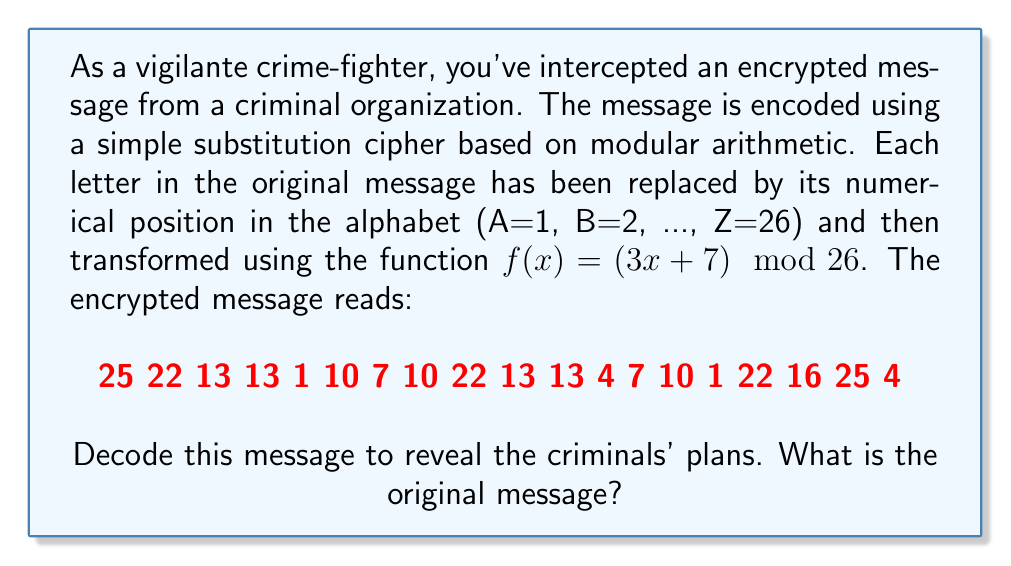Give your solution to this math problem. To decode the message, we need to reverse the encryption process:

1) First, we need to find the inverse function of $f(x) = (3x + 7) \mod 26$. 
   Let $y = (3x + 7) \mod 26$
   Then $y - 7 \equiv 3x \pmod{26}$
   Multiply both sides by the modular multiplicative inverse of 3 (mod 26), which is 9:
   $9(y - 7) \equiv x \pmod{26}$
   $9y - 63 \equiv x \pmod{26}$
   $9y + 15 \equiv x \pmod{26}$ (since -63 ≡ 15 (mod 26))

   So the inverse function is $f^{-1}(y) = (9y + 15) \mod 26$

2) Apply this inverse function to each number in the encrypted message:

   25 → (9(25) + 15) mod 26 = 240 mod 26 = 6
   22 → (9(22) + 15) mod 26 = 213 mod 26 = 5
   13 → (9(13) + 15) mod 26 = 132 mod 26 = 2
   1  → (9(1) + 15) mod 26 = 24 mod 26 = 24
   10 → (9(10) + 15) mod 26 = 105 mod 26 = 1
   7  → (9(7) + 15) mod 26 = 78 mod 26 = 0 (which corresponds to 26)
   4  → (9(4) + 15) mod 26 = 51 mod 26 = 25
   16 → (9(16) + 15) mod 26 = 159 mod 26 = 3

3) Convert these numbers back to letters (remember 26 corresponds to Z):

   6 5 2 2 24 1 26 1 5 2 2 25 26 1 24 5 3 6 25

4) Replace each number with its corresponding letter:

   F E B B X A Z A E B B Y Z A X E C F Y

5) The decoded message reads: "FEBBXAZAEBBYZAXECFY"
Answer: The original message is: FEBBXAZAEBBYZAXECFY 